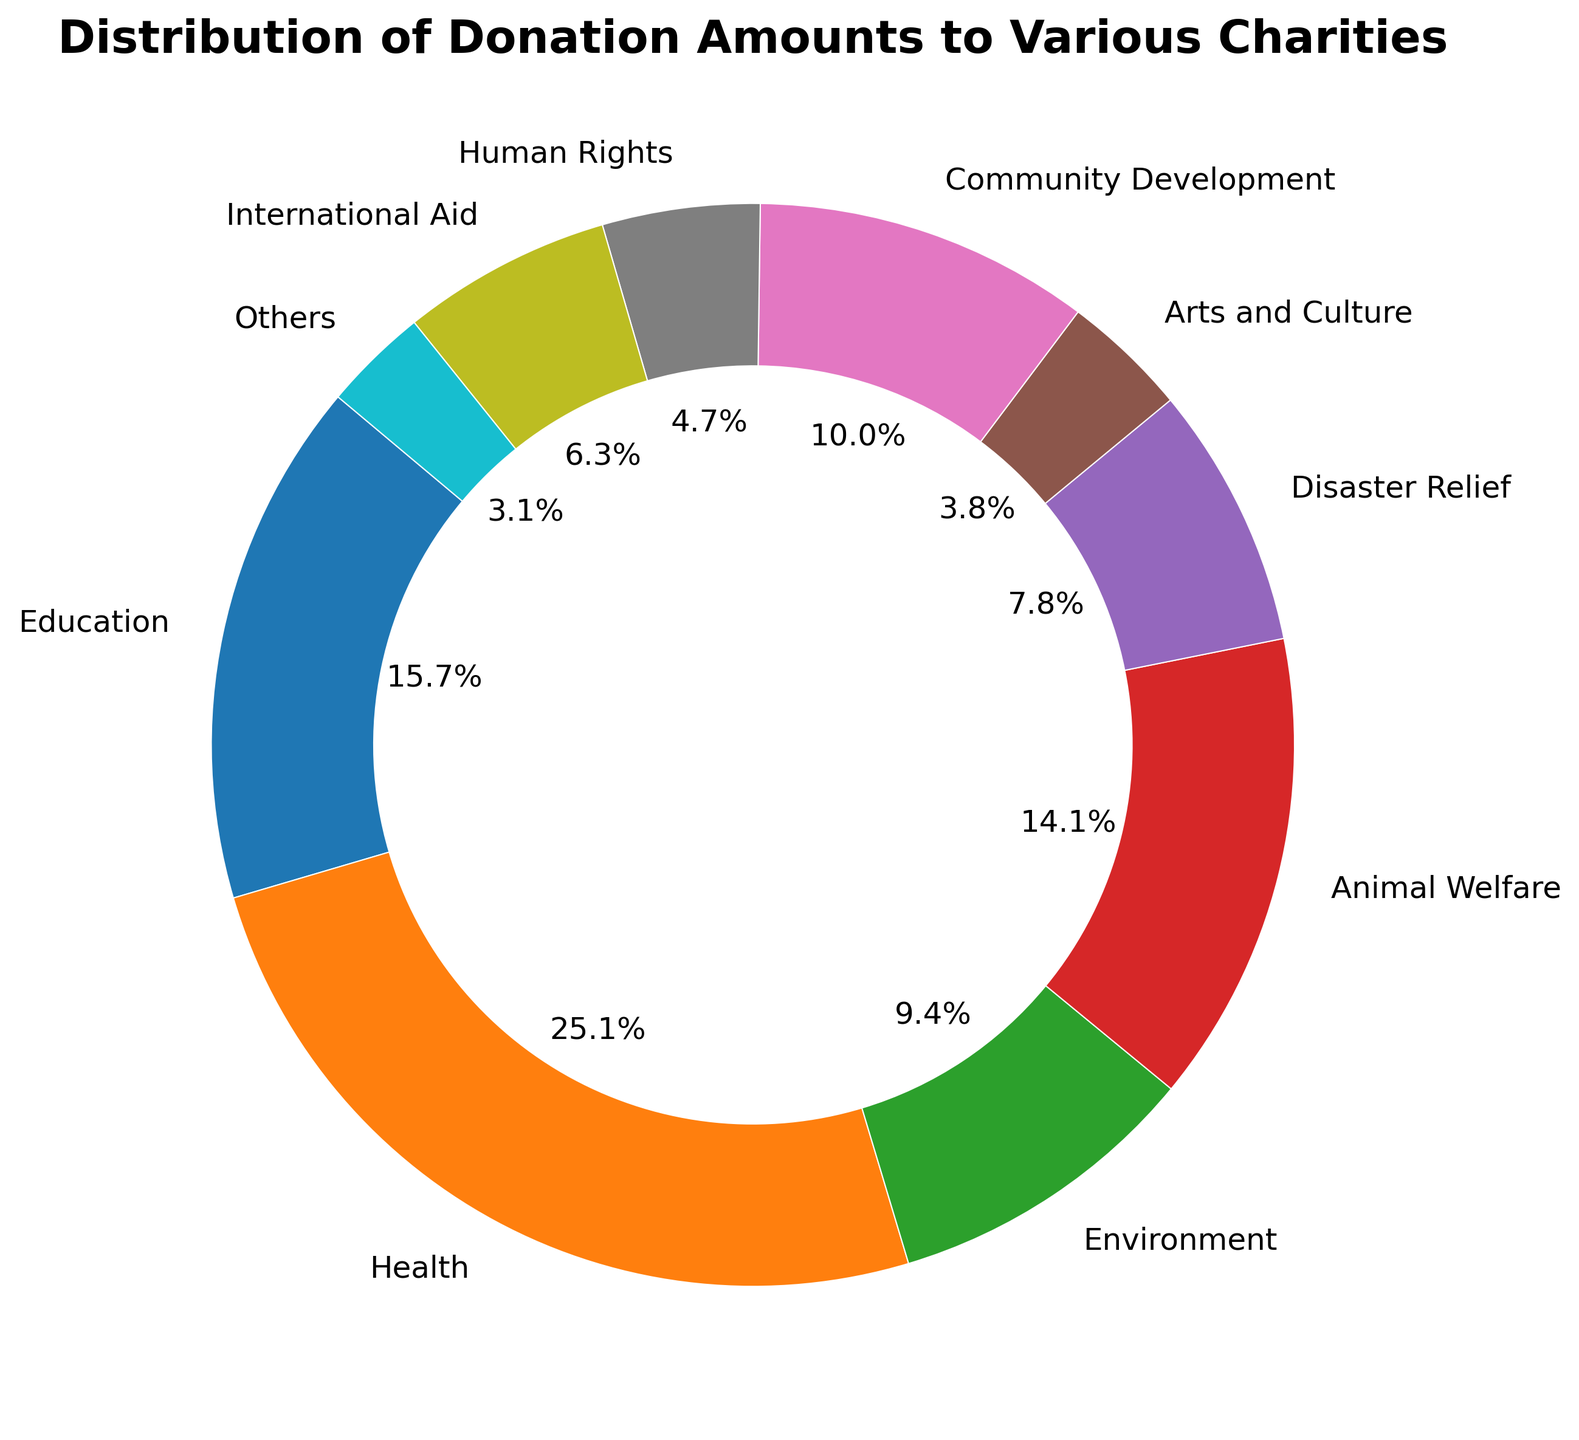What percentage of the total donations is given to Animal Welfare? To find this percentage, look at the pie chart section for Animal Welfare. The value shown on the chart will be the answer.
Answer: 15.7% Which charity type receives the highest percentage of donations? Identify the largest segment in the pie chart. The label of this segment will indicate the charity type with the highest percentage.
Answer: Health Between Arts and Culture and Community Development, which receives more donations? Compare the sizes of the segments for Arts and Culture and Community Development in the pie chart. The larger segment represents the charity type receiving more donations.
Answer: Community Development What is the combined percentage of donations for Education and Health? Identify the percentages for Education and Health individually on the pie chart and add them together.
Answer: 32.9% How does the donation percentage for Environment compare to that for Disaster Relief? Compare the segments for Environment and Disaster Relief. Check which one is larger or if they are the same size to understand their relative percentages.
Answer: Environment is larger If donations to Human Rights and International Aid were combined, what would be their percentage of the total donations? Find the percentages for Human Rights and International Aid, add them together for the combined total.
Answer: 6.1% What is the percentage difference between donations to Health and Education? Identify the percentages for Health and Education from the pie chart and subtract the smaller from the larger to get the difference.
Answer: 8.6% Which charity type receives the smallest donation amount and what is its percentage? Identify the smallest segment in the pie chart. The label of this segment will indicate the charity type. Look at the percentage shown in the segment.
Answer: Others, 3.9% How many charity types receive less than 10% each of the total donations? Count the segments in the pie chart that have a percentage less than 10%.
Answer: 6 What do the largest and smallest segments in the pie chart represent in terms of charity types and donation amounts? Identify the largest and smallest segments and their labels. These will give the charity types. Refer to the percentage and labels to get the donation amounts.
Answer: Health ($8000) and Others ($1000) 